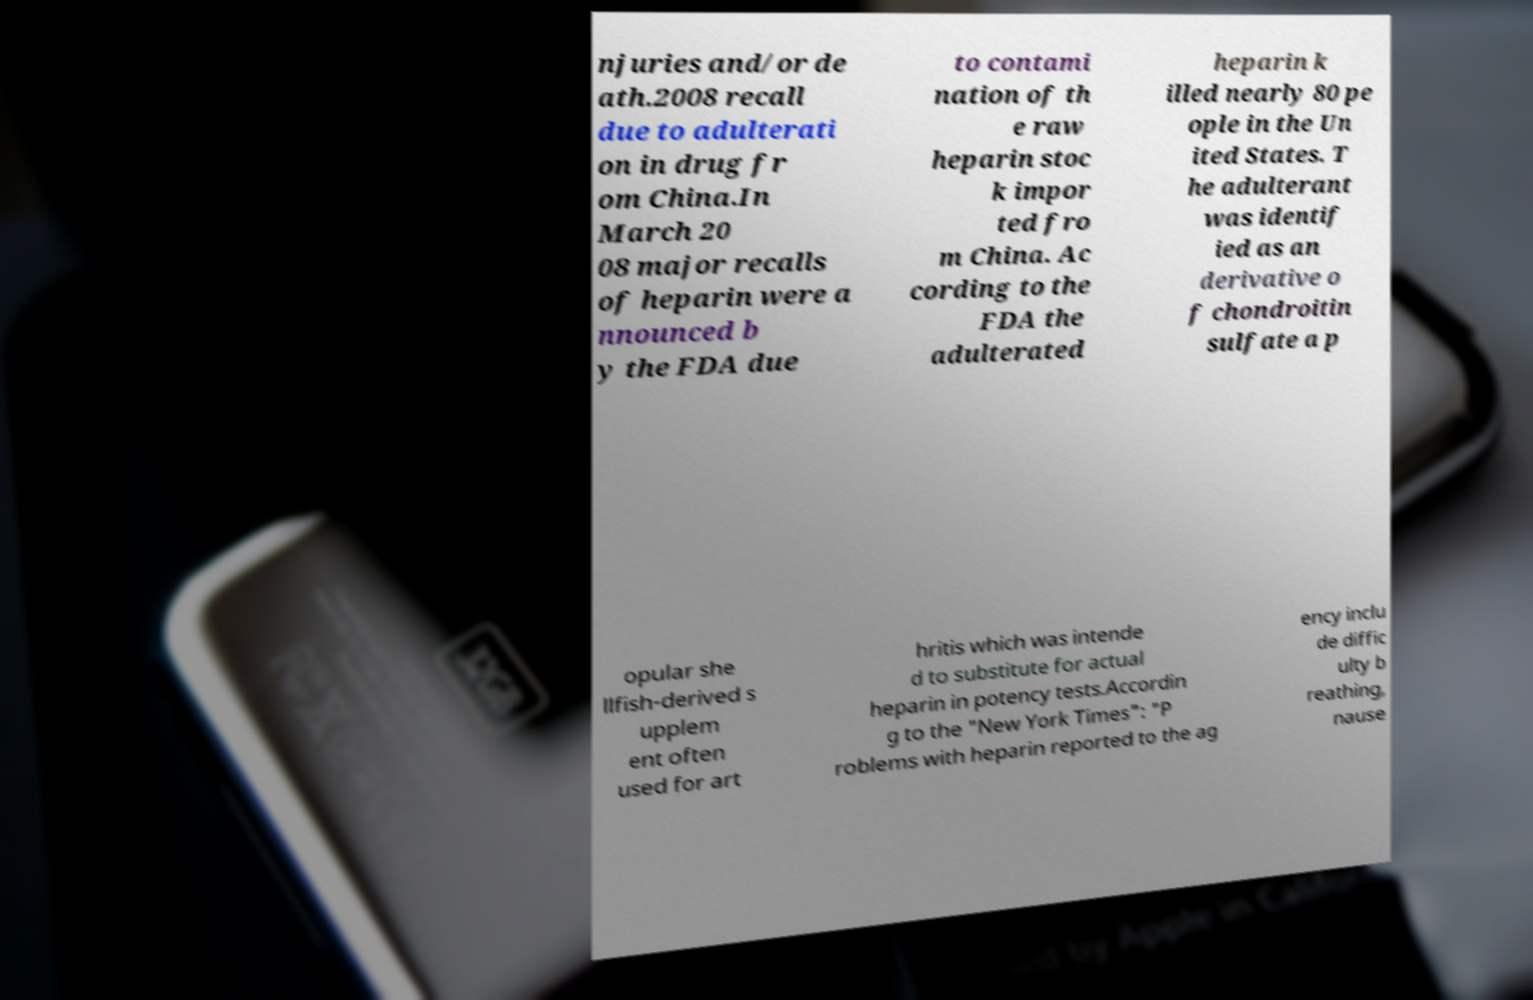What messages or text are displayed in this image? I need them in a readable, typed format. njuries and/or de ath.2008 recall due to adulterati on in drug fr om China.In March 20 08 major recalls of heparin were a nnounced b y the FDA due to contami nation of th e raw heparin stoc k impor ted fro m China. Ac cording to the FDA the adulterated heparin k illed nearly 80 pe ople in the Un ited States. T he adulterant was identif ied as an derivative o f chondroitin sulfate a p opular she llfish-derived s upplem ent often used for art hritis which was intende d to substitute for actual heparin in potency tests.Accordin g to the "New York Times": "P roblems with heparin reported to the ag ency inclu de diffic ulty b reathing, nause 